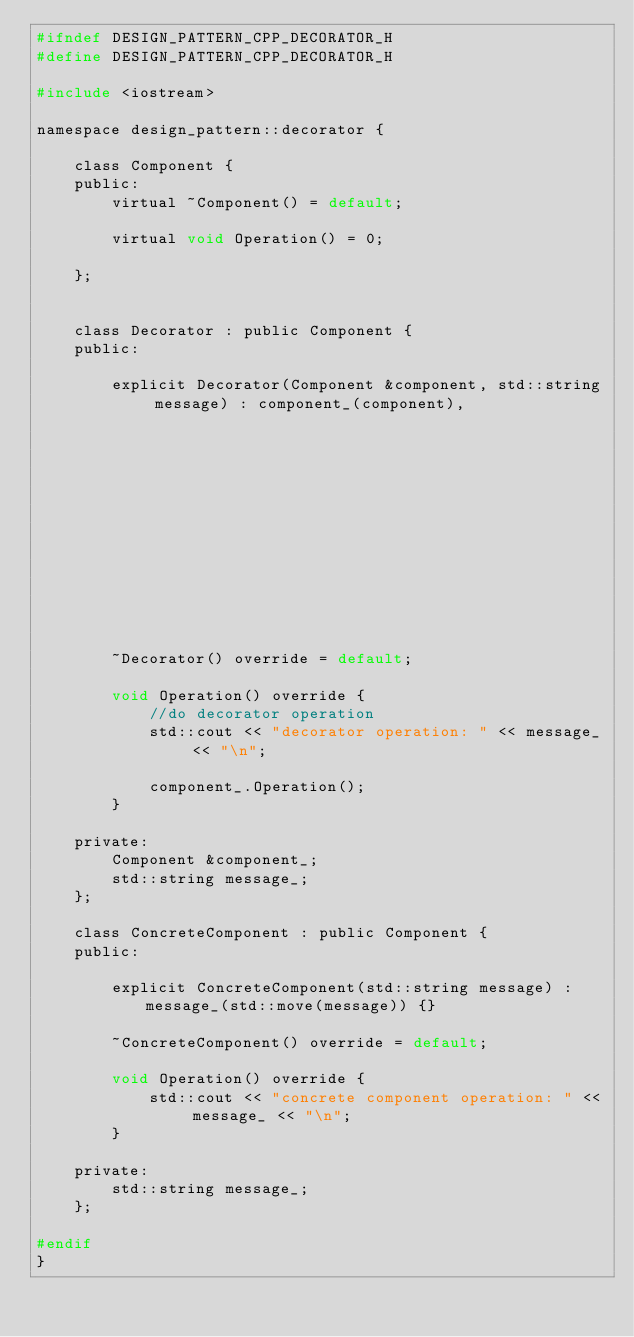<code> <loc_0><loc_0><loc_500><loc_500><_C_>#ifndef DESIGN_PATTERN_CPP_DECORATOR_H
#define DESIGN_PATTERN_CPP_DECORATOR_H

#include <iostream>

namespace design_pattern::decorator {

    class Component {
    public:
        virtual ~Component() = default;

        virtual void Operation() = 0;

    };


    class Decorator : public Component {
    public:

        explicit Decorator(Component &component, std::string message) : component_(component),
                                                                        message_(std::move(message)) {}

        ~Decorator() override = default;

        void Operation() override {
            //do decorator operation
            std::cout << "decorator operation: " << message_ << "\n";

            component_.Operation();
        }

    private:
        Component &component_;
        std::string message_;
    };

    class ConcreteComponent : public Component {
    public:

        explicit ConcreteComponent(std::string message) : message_(std::move(message)) {}

        ~ConcreteComponent() override = default;

        void Operation() override {
            std::cout << "concrete component operation: " << message_ << "\n";
        }

    private:
        std::string message_;
    };

#endif
}</code> 